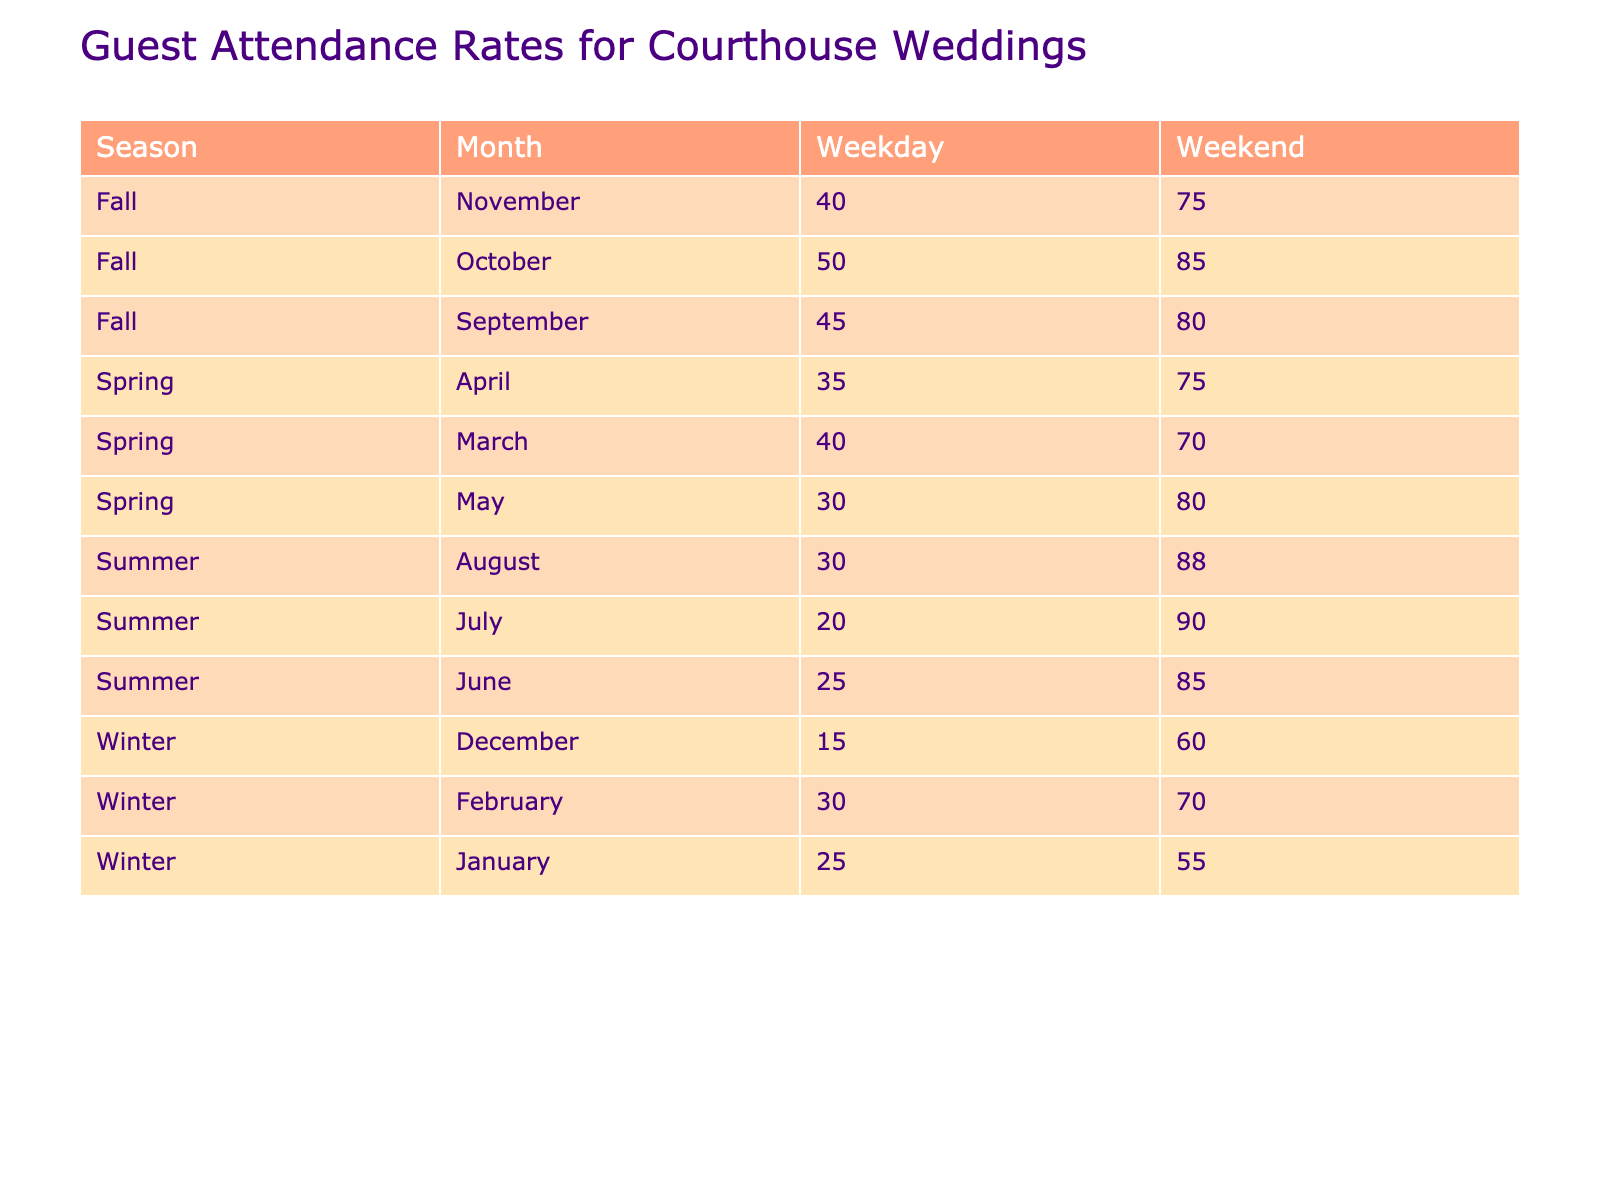What is the guest attendance rate for courthouse weddings in March on a weekend? Looking at the table, in March, under the Weekend column, the Guest Attendance Rate is 70%.
Answer: 70 Which month in Spring has the highest guest attendance rate on a weekday? In the Spring section, we can see the following weekday rates: March: 40%, April: 35%, May: 30%. The highest attendance rate is 40% in March.
Answer: 40 What is the average guest attendance rate for all weekends in Summer? Summing the guest attendance rates for the weekend in Summer: June: 85%, July: 90%, August: 88%. Adding these gives us 85 + 90 + 88 = 263. There are 3 months, so dividing by 3 gives 263/3 = about 87.67.
Answer: Approximately 87.67 Is the guest attendance rate in Winter higher on weekends or weekdays? Looking at the table for Winter: weekday rates are December: 15%, January: 25%, February: 30%; weekend rates are December: 60%, January: 55%, February: 70%. The weekend average is 61.67% (60 + 55 + 70) / 3 and the weekday average is 23.33% (15 + 25 + 30) / 3. Since 61.67% > 23.33%, weekends have higher rates.
Answer: Yes In which season do the guests show the least attendance on weekdays? For weekdays, the lowest rates from each season are: Spring: 30%, Summer: 20%, Fall: 40%, Winter: 15%. Since 15% is the smallest number, the least attendance occurs in Winter.
Answer: Winter What is the difference in guest attendance between weekend and weekday in October? In October, the weekday attendance is 50% and the weekend attendance is 85%. The difference is 85 - 50 = 35%.
Answer: 35 Which month in Fall has the highest guest attendance on a weekend? In Fall, the weekend rates are September: 80%, October: 85%, November: 75%. The highest is in October at 85%.
Answer: October Is there a month in Spring where the weekend attendance rate is lower than 75%? In Spring, the weekend rates are March: 70%, April: 75%, May: 80%. Only March at 70% is lower than 75%.
Answer: Yes 